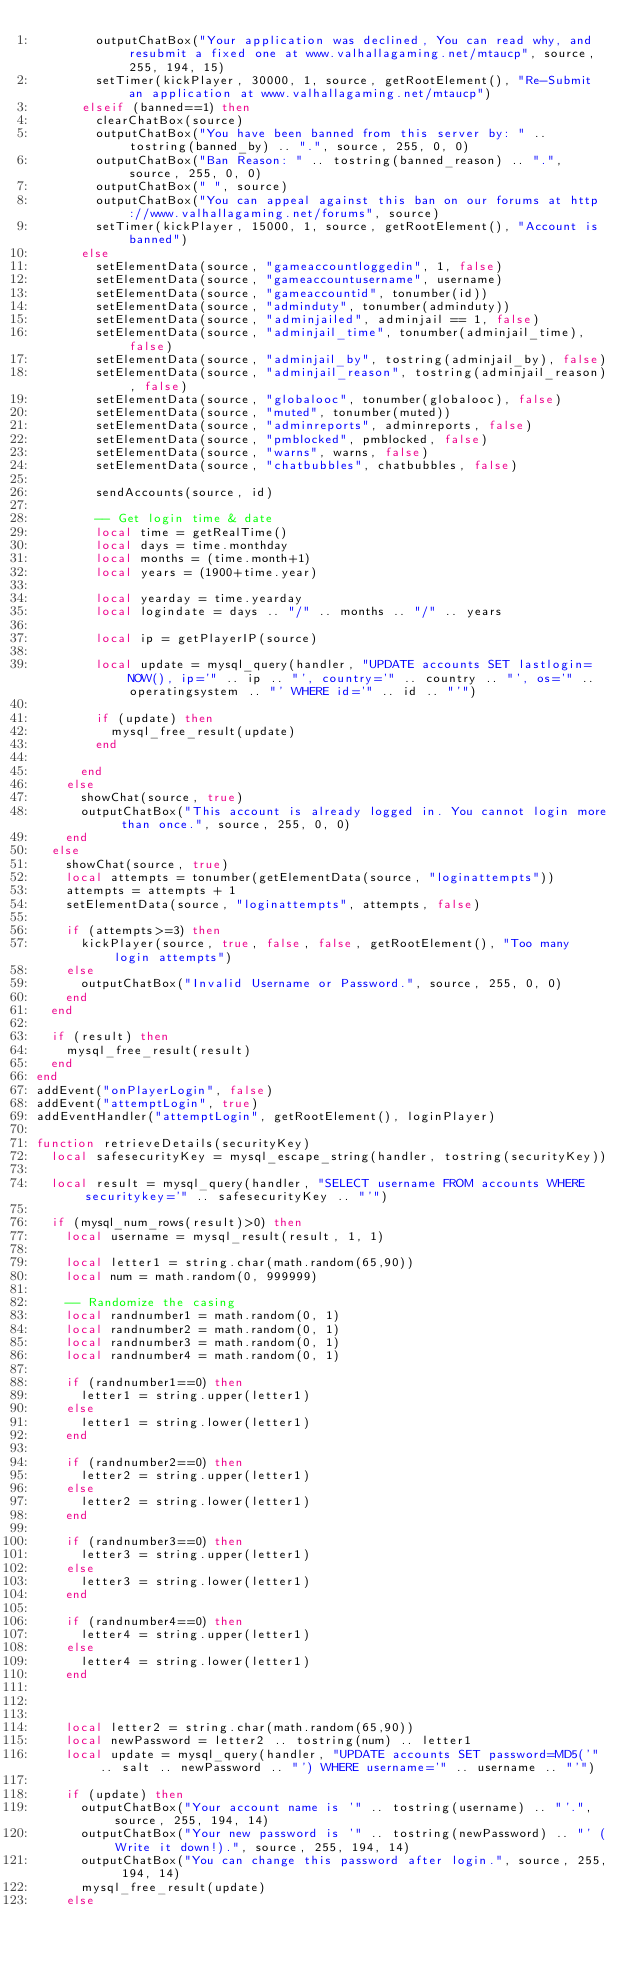Convert code to text. <code><loc_0><loc_0><loc_500><loc_500><_Lua_>				outputChatBox("Your application was declined, You can read why, and resubmit a fixed one at www.valhallagaming.net/mtaucp", source, 255, 194, 15)
				setTimer(kickPlayer, 30000, 1, source, getRootElement(), "Re-Submit an application at www.valhallagaming.net/mtaucp")
			elseif (banned==1) then
				clearChatBox(source)
				outputChatBox("You have been banned from this server by: " .. tostring(banned_by) .. ".", source, 255, 0, 0)
				outputChatBox("Ban Reason: " .. tostring(banned_reason) .. ".", source, 255, 0, 0)
				outputChatBox(" ", source)
				outputChatBox("You can appeal against this ban on our forums at http://www.valhallagaming.net/forums", source)
				setTimer(kickPlayer, 15000, 1, source, getRootElement(), "Account is banned")
			else
				setElementData(source, "gameaccountloggedin", 1, false)
				setElementData(source, "gameaccountusername", username)
				setElementData(source, "gameaccountid", tonumber(id))
				setElementData(source, "adminduty", tonumber(adminduty))
				setElementData(source, "adminjailed", adminjail == 1, false)
				setElementData(source, "adminjail_time", tonumber(adminjail_time), false)
				setElementData(source, "adminjail_by", tostring(adminjail_by), false)
				setElementData(source, "adminjail_reason", tostring(adminjail_reason), false)
				setElementData(source, "globalooc", tonumber(globalooc), false)
				setElementData(source, "muted", tonumber(muted))
				setElementData(source, "adminreports", adminreports, false)
				setElementData(source, "pmblocked", pmblocked, false)
				setElementData(source, "warns", warns, false)
				setElementData(source, "chatbubbles", chatbubbles, false)
				
				sendAccounts(source, id)
				
				-- Get login time & date
				local time = getRealTime()
				local days = time.monthday
				local months = (time.month+1)
				local years = (1900+time.year)
				
				local yearday = time.yearday
				local logindate = days .. "/" .. months .. "/" .. years
				
				local ip = getPlayerIP(source)
				
				local update = mysql_query(handler, "UPDATE accounts SET lastlogin=NOW(), ip='" .. ip .. "', country='" .. country .. "', os='" .. operatingsystem .. "' WHERE id='" .. id .. "'")
				
				if (update) then
					mysql_free_result(update)
				end
				
			end
		else
			showChat(source, true)
			outputChatBox("This account is already logged in. You cannot login more than once.", source, 255, 0, 0)
		end
	else
		showChat(source, true)
		local attempts = tonumber(getElementData(source, "loginattempts"))
		attempts = attempts + 1
		setElementData(source, "loginattempts", attempts, false)
		
		if (attempts>=3) then
			kickPlayer(source, true, false, false, getRootElement(), "Too many login attempts")
		else
			outputChatBox("Invalid Username or Password.", source, 255, 0, 0)
		end
	end
	
	if (result) then
		mysql_free_result(result)
	end
end
addEvent("onPlayerLogin", false)
addEvent("attemptLogin", true)
addEventHandler("attemptLogin", getRootElement(), loginPlayer)

function retrieveDetails(securityKey)
	local safesecurityKey = mysql_escape_string(handler, tostring(securityKey))

	local result = mysql_query(handler, "SELECT username FROM accounts WHERE securitykey='" .. safesecurityKey .. "'")

	if (mysql_num_rows(result)>0) then
		local username = mysql_result(result, 1, 1)

		local letter1 = string.char(math.random(65,90))
		local num = math.random(0, 999999)
		
		-- Randomize the casing
		local randnumber1 = math.random(0, 1)
		local randnumber2 = math.random(0, 1)
		local randnumber3 = math.random(0, 1)
		local randnumber4 = math.random(0, 1)
		
		if (randnumber1==0) then
			letter1 = string.upper(letter1)
		else
			letter1 = string.lower(letter1)
		end
		
		if (randnumber2==0) then
			letter2 = string.upper(letter1)
		else
			letter2 = string.lower(letter1)
		end
		
		if (randnumber3==0) then
			letter3 = string.upper(letter1)
		else
			letter3 = string.lower(letter1)
		end
		
		if (randnumber4==0) then
			letter4 = string.upper(letter1)
		else
			letter4 = string.lower(letter1)
		end
		
		
		
		local letter2 = string.char(math.random(65,90))
		local newPassword = letter2 .. tostring(num) .. letter1
		local update = mysql_query(handler, "UPDATE accounts SET password=MD5('" .. salt .. newPassword .. "') WHERE username='" .. username .. "'")
		
		if (update) then
			outputChatBox("Your account name is '" .. tostring(username) .. "'.", source, 255, 194, 14)
			outputChatBox("Your new password is '" .. tostring(newPassword) .. "' (Write it down!).", source, 255, 194, 14)
			outputChatBox("You can change this password after login.", source, 255, 194, 14)
			mysql_free_result(update)
		else</code> 